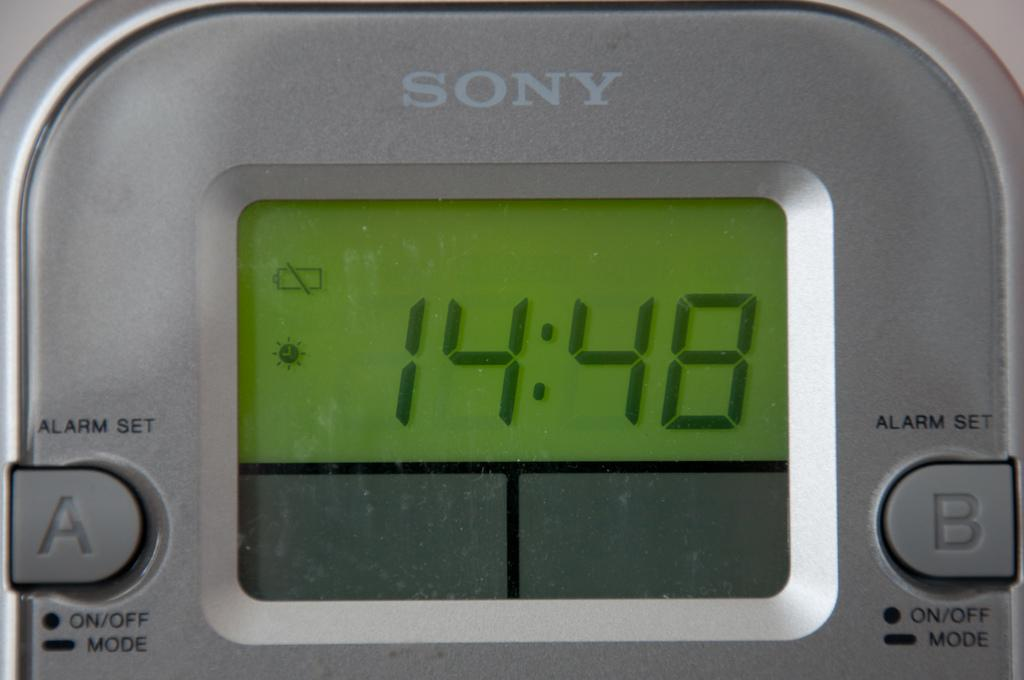<image>
Present a compact description of the photo's key features. A Sony electronic display with the readout 14:48 in front of a green background. 